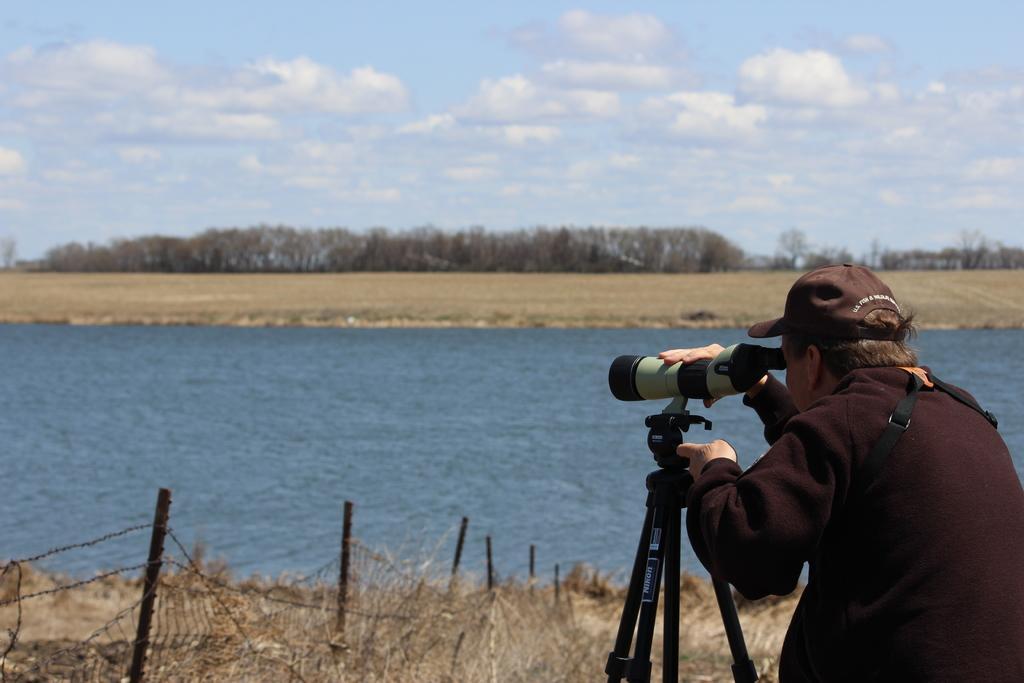In one or two sentences, can you explain what this image depicts? In this image there is a person standing on the ground. The person is wearing a cap. In front of the person there is a camera on the tripod stand. To the left there is a fence on the ground. Behind the fence where is the water. In the background there are trees on the ground. At the top there is the sky. 